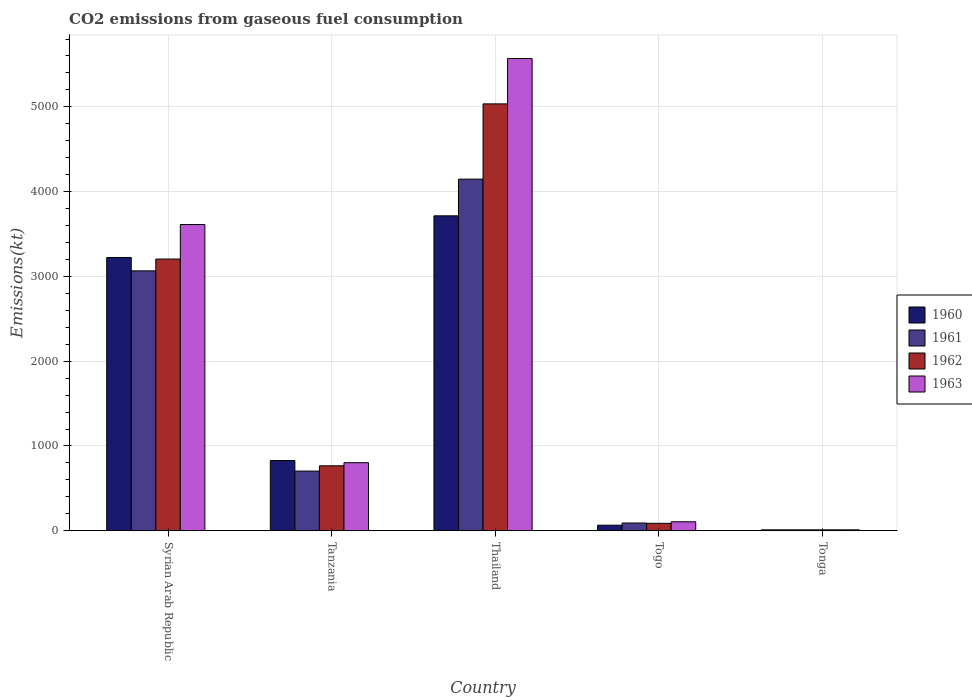How many different coloured bars are there?
Offer a terse response. 4. How many groups of bars are there?
Provide a short and direct response. 5. Are the number of bars per tick equal to the number of legend labels?
Ensure brevity in your answer.  Yes. Are the number of bars on each tick of the X-axis equal?
Provide a succinct answer. Yes. What is the label of the 4th group of bars from the left?
Make the answer very short. Togo. In how many cases, is the number of bars for a given country not equal to the number of legend labels?
Keep it short and to the point. 0. What is the amount of CO2 emitted in 1960 in Syrian Arab Republic?
Your answer should be very brief. 3223.29. Across all countries, what is the maximum amount of CO2 emitted in 1962?
Give a very brief answer. 5034.79. Across all countries, what is the minimum amount of CO2 emitted in 1960?
Your answer should be compact. 11. In which country was the amount of CO2 emitted in 1961 maximum?
Your answer should be very brief. Thailand. In which country was the amount of CO2 emitted in 1960 minimum?
Ensure brevity in your answer.  Tonga. What is the total amount of CO2 emitted in 1962 in the graph?
Provide a succinct answer. 9105.16. What is the difference between the amount of CO2 emitted in 1962 in Tanzania and that in Tonga?
Offer a terse response. 755.4. What is the difference between the amount of CO2 emitted in 1960 in Tanzania and the amount of CO2 emitted in 1962 in Thailand?
Give a very brief answer. -4206.05. What is the average amount of CO2 emitted in 1960 per country?
Provide a succinct answer. 1568.74. What is the difference between the amount of CO2 emitted of/in 1962 and amount of CO2 emitted of/in 1963 in Thailand?
Provide a short and direct response. -535.38. What is the ratio of the amount of CO2 emitted in 1961 in Thailand to that in Togo?
Give a very brief answer. 45.24. Is the difference between the amount of CO2 emitted in 1962 in Togo and Tonga greater than the difference between the amount of CO2 emitted in 1963 in Togo and Tonga?
Your answer should be very brief. No. What is the difference between the highest and the second highest amount of CO2 emitted in 1962?
Offer a very short reply. 1829.83. What is the difference between the highest and the lowest amount of CO2 emitted in 1961?
Your answer should be compact. 4136.38. In how many countries, is the amount of CO2 emitted in 1961 greater than the average amount of CO2 emitted in 1961 taken over all countries?
Provide a succinct answer. 2. Is it the case that in every country, the sum of the amount of CO2 emitted in 1962 and amount of CO2 emitted in 1963 is greater than the sum of amount of CO2 emitted in 1961 and amount of CO2 emitted in 1960?
Offer a terse response. No. What does the 4th bar from the right in Thailand represents?
Make the answer very short. 1960. Are all the bars in the graph horizontal?
Your response must be concise. No. How many countries are there in the graph?
Offer a terse response. 5. Does the graph contain any zero values?
Provide a succinct answer. No. Does the graph contain grids?
Your response must be concise. Yes. Where does the legend appear in the graph?
Keep it short and to the point. Center right. How many legend labels are there?
Your answer should be very brief. 4. What is the title of the graph?
Offer a terse response. CO2 emissions from gaseous fuel consumption. What is the label or title of the Y-axis?
Ensure brevity in your answer.  Emissions(kt). What is the Emissions(kt) of 1960 in Syrian Arab Republic?
Your answer should be very brief. 3223.29. What is the Emissions(kt) of 1961 in Syrian Arab Republic?
Offer a very short reply. 3065.61. What is the Emissions(kt) in 1962 in Syrian Arab Republic?
Ensure brevity in your answer.  3204.96. What is the Emissions(kt) of 1963 in Syrian Arab Republic?
Provide a succinct answer. 3611.99. What is the Emissions(kt) of 1960 in Tanzania?
Give a very brief answer. 828.74. What is the Emissions(kt) in 1961 in Tanzania?
Your answer should be compact. 704.06. What is the Emissions(kt) in 1962 in Tanzania?
Your response must be concise. 766.4. What is the Emissions(kt) in 1963 in Tanzania?
Give a very brief answer. 803.07. What is the Emissions(kt) in 1960 in Thailand?
Your response must be concise. 3714.67. What is the Emissions(kt) in 1961 in Thailand?
Provide a short and direct response. 4147.38. What is the Emissions(kt) of 1962 in Thailand?
Give a very brief answer. 5034.79. What is the Emissions(kt) in 1963 in Thailand?
Offer a very short reply. 5570.17. What is the Emissions(kt) of 1960 in Togo?
Ensure brevity in your answer.  66.01. What is the Emissions(kt) of 1961 in Togo?
Keep it short and to the point. 91.67. What is the Emissions(kt) of 1962 in Togo?
Your answer should be very brief. 88.01. What is the Emissions(kt) of 1963 in Togo?
Give a very brief answer. 106.34. What is the Emissions(kt) in 1960 in Tonga?
Offer a very short reply. 11. What is the Emissions(kt) in 1961 in Tonga?
Your answer should be compact. 11. What is the Emissions(kt) of 1962 in Tonga?
Keep it short and to the point. 11. What is the Emissions(kt) of 1963 in Tonga?
Give a very brief answer. 11. Across all countries, what is the maximum Emissions(kt) in 1960?
Provide a succinct answer. 3714.67. Across all countries, what is the maximum Emissions(kt) of 1961?
Provide a short and direct response. 4147.38. Across all countries, what is the maximum Emissions(kt) of 1962?
Provide a short and direct response. 5034.79. Across all countries, what is the maximum Emissions(kt) in 1963?
Your answer should be very brief. 5570.17. Across all countries, what is the minimum Emissions(kt) in 1960?
Offer a terse response. 11. Across all countries, what is the minimum Emissions(kt) of 1961?
Your answer should be compact. 11. Across all countries, what is the minimum Emissions(kt) in 1962?
Provide a short and direct response. 11. Across all countries, what is the minimum Emissions(kt) in 1963?
Your response must be concise. 11. What is the total Emissions(kt) in 1960 in the graph?
Keep it short and to the point. 7843.71. What is the total Emissions(kt) in 1961 in the graph?
Your answer should be compact. 8019.73. What is the total Emissions(kt) of 1962 in the graph?
Ensure brevity in your answer.  9105.16. What is the total Emissions(kt) of 1963 in the graph?
Provide a succinct answer. 1.01e+04. What is the difference between the Emissions(kt) in 1960 in Syrian Arab Republic and that in Tanzania?
Your response must be concise. 2394.55. What is the difference between the Emissions(kt) of 1961 in Syrian Arab Republic and that in Tanzania?
Provide a short and direct response. 2361.55. What is the difference between the Emissions(kt) in 1962 in Syrian Arab Republic and that in Tanzania?
Keep it short and to the point. 2438.55. What is the difference between the Emissions(kt) of 1963 in Syrian Arab Republic and that in Tanzania?
Provide a short and direct response. 2808.92. What is the difference between the Emissions(kt) of 1960 in Syrian Arab Republic and that in Thailand?
Provide a succinct answer. -491.38. What is the difference between the Emissions(kt) in 1961 in Syrian Arab Republic and that in Thailand?
Your response must be concise. -1081.77. What is the difference between the Emissions(kt) of 1962 in Syrian Arab Republic and that in Thailand?
Your response must be concise. -1829.83. What is the difference between the Emissions(kt) in 1963 in Syrian Arab Republic and that in Thailand?
Give a very brief answer. -1958.18. What is the difference between the Emissions(kt) in 1960 in Syrian Arab Republic and that in Togo?
Offer a very short reply. 3157.29. What is the difference between the Emissions(kt) in 1961 in Syrian Arab Republic and that in Togo?
Keep it short and to the point. 2973.94. What is the difference between the Emissions(kt) of 1962 in Syrian Arab Republic and that in Togo?
Make the answer very short. 3116.95. What is the difference between the Emissions(kt) in 1963 in Syrian Arab Republic and that in Togo?
Offer a terse response. 3505.65. What is the difference between the Emissions(kt) of 1960 in Syrian Arab Republic and that in Tonga?
Keep it short and to the point. 3212.29. What is the difference between the Emissions(kt) of 1961 in Syrian Arab Republic and that in Tonga?
Offer a terse response. 3054.61. What is the difference between the Emissions(kt) in 1962 in Syrian Arab Republic and that in Tonga?
Provide a short and direct response. 3193.96. What is the difference between the Emissions(kt) of 1963 in Syrian Arab Republic and that in Tonga?
Your answer should be compact. 3600.99. What is the difference between the Emissions(kt) in 1960 in Tanzania and that in Thailand?
Your response must be concise. -2885.93. What is the difference between the Emissions(kt) in 1961 in Tanzania and that in Thailand?
Your response must be concise. -3443.31. What is the difference between the Emissions(kt) of 1962 in Tanzania and that in Thailand?
Give a very brief answer. -4268.39. What is the difference between the Emissions(kt) of 1963 in Tanzania and that in Thailand?
Keep it short and to the point. -4767.1. What is the difference between the Emissions(kt) in 1960 in Tanzania and that in Togo?
Make the answer very short. 762.74. What is the difference between the Emissions(kt) in 1961 in Tanzania and that in Togo?
Make the answer very short. 612.39. What is the difference between the Emissions(kt) in 1962 in Tanzania and that in Togo?
Your answer should be compact. 678.39. What is the difference between the Emissions(kt) in 1963 in Tanzania and that in Togo?
Ensure brevity in your answer.  696.73. What is the difference between the Emissions(kt) in 1960 in Tanzania and that in Tonga?
Your response must be concise. 817.74. What is the difference between the Emissions(kt) in 1961 in Tanzania and that in Tonga?
Ensure brevity in your answer.  693.06. What is the difference between the Emissions(kt) of 1962 in Tanzania and that in Tonga?
Make the answer very short. 755.4. What is the difference between the Emissions(kt) in 1963 in Tanzania and that in Tonga?
Offer a very short reply. 792.07. What is the difference between the Emissions(kt) in 1960 in Thailand and that in Togo?
Offer a terse response. 3648.66. What is the difference between the Emissions(kt) of 1961 in Thailand and that in Togo?
Offer a terse response. 4055.7. What is the difference between the Emissions(kt) of 1962 in Thailand and that in Togo?
Your response must be concise. 4946.78. What is the difference between the Emissions(kt) of 1963 in Thailand and that in Togo?
Give a very brief answer. 5463.83. What is the difference between the Emissions(kt) of 1960 in Thailand and that in Tonga?
Offer a terse response. 3703.67. What is the difference between the Emissions(kt) of 1961 in Thailand and that in Tonga?
Your answer should be very brief. 4136.38. What is the difference between the Emissions(kt) of 1962 in Thailand and that in Tonga?
Your response must be concise. 5023.79. What is the difference between the Emissions(kt) of 1963 in Thailand and that in Tonga?
Your answer should be compact. 5559.17. What is the difference between the Emissions(kt) in 1960 in Togo and that in Tonga?
Ensure brevity in your answer.  55.01. What is the difference between the Emissions(kt) in 1961 in Togo and that in Tonga?
Your answer should be very brief. 80.67. What is the difference between the Emissions(kt) of 1962 in Togo and that in Tonga?
Provide a short and direct response. 77.01. What is the difference between the Emissions(kt) in 1963 in Togo and that in Tonga?
Your answer should be compact. 95.34. What is the difference between the Emissions(kt) in 1960 in Syrian Arab Republic and the Emissions(kt) in 1961 in Tanzania?
Offer a terse response. 2519.23. What is the difference between the Emissions(kt) of 1960 in Syrian Arab Republic and the Emissions(kt) of 1962 in Tanzania?
Ensure brevity in your answer.  2456.89. What is the difference between the Emissions(kt) in 1960 in Syrian Arab Republic and the Emissions(kt) in 1963 in Tanzania?
Make the answer very short. 2420.22. What is the difference between the Emissions(kt) of 1961 in Syrian Arab Republic and the Emissions(kt) of 1962 in Tanzania?
Give a very brief answer. 2299.21. What is the difference between the Emissions(kt) in 1961 in Syrian Arab Republic and the Emissions(kt) in 1963 in Tanzania?
Your answer should be very brief. 2262.54. What is the difference between the Emissions(kt) of 1962 in Syrian Arab Republic and the Emissions(kt) of 1963 in Tanzania?
Make the answer very short. 2401.89. What is the difference between the Emissions(kt) in 1960 in Syrian Arab Republic and the Emissions(kt) in 1961 in Thailand?
Provide a short and direct response. -924.08. What is the difference between the Emissions(kt) in 1960 in Syrian Arab Republic and the Emissions(kt) in 1962 in Thailand?
Your answer should be compact. -1811.5. What is the difference between the Emissions(kt) in 1960 in Syrian Arab Republic and the Emissions(kt) in 1963 in Thailand?
Make the answer very short. -2346.88. What is the difference between the Emissions(kt) of 1961 in Syrian Arab Republic and the Emissions(kt) of 1962 in Thailand?
Provide a short and direct response. -1969.18. What is the difference between the Emissions(kt) of 1961 in Syrian Arab Republic and the Emissions(kt) of 1963 in Thailand?
Your answer should be compact. -2504.56. What is the difference between the Emissions(kt) of 1962 in Syrian Arab Republic and the Emissions(kt) of 1963 in Thailand?
Make the answer very short. -2365.22. What is the difference between the Emissions(kt) of 1960 in Syrian Arab Republic and the Emissions(kt) of 1961 in Togo?
Keep it short and to the point. 3131.62. What is the difference between the Emissions(kt) in 1960 in Syrian Arab Republic and the Emissions(kt) in 1962 in Togo?
Ensure brevity in your answer.  3135.28. What is the difference between the Emissions(kt) in 1960 in Syrian Arab Republic and the Emissions(kt) in 1963 in Togo?
Your answer should be compact. 3116.95. What is the difference between the Emissions(kt) of 1961 in Syrian Arab Republic and the Emissions(kt) of 1962 in Togo?
Give a very brief answer. 2977.6. What is the difference between the Emissions(kt) of 1961 in Syrian Arab Republic and the Emissions(kt) of 1963 in Togo?
Provide a succinct answer. 2959.27. What is the difference between the Emissions(kt) in 1962 in Syrian Arab Republic and the Emissions(kt) in 1963 in Togo?
Your response must be concise. 3098.61. What is the difference between the Emissions(kt) of 1960 in Syrian Arab Republic and the Emissions(kt) of 1961 in Tonga?
Make the answer very short. 3212.29. What is the difference between the Emissions(kt) in 1960 in Syrian Arab Republic and the Emissions(kt) in 1962 in Tonga?
Keep it short and to the point. 3212.29. What is the difference between the Emissions(kt) of 1960 in Syrian Arab Republic and the Emissions(kt) of 1963 in Tonga?
Offer a terse response. 3212.29. What is the difference between the Emissions(kt) of 1961 in Syrian Arab Republic and the Emissions(kt) of 1962 in Tonga?
Ensure brevity in your answer.  3054.61. What is the difference between the Emissions(kt) of 1961 in Syrian Arab Republic and the Emissions(kt) of 1963 in Tonga?
Your answer should be compact. 3054.61. What is the difference between the Emissions(kt) in 1962 in Syrian Arab Republic and the Emissions(kt) in 1963 in Tonga?
Offer a terse response. 3193.96. What is the difference between the Emissions(kt) of 1960 in Tanzania and the Emissions(kt) of 1961 in Thailand?
Provide a short and direct response. -3318.64. What is the difference between the Emissions(kt) in 1960 in Tanzania and the Emissions(kt) in 1962 in Thailand?
Your answer should be compact. -4206.05. What is the difference between the Emissions(kt) of 1960 in Tanzania and the Emissions(kt) of 1963 in Thailand?
Keep it short and to the point. -4741.43. What is the difference between the Emissions(kt) of 1961 in Tanzania and the Emissions(kt) of 1962 in Thailand?
Your answer should be compact. -4330.73. What is the difference between the Emissions(kt) in 1961 in Tanzania and the Emissions(kt) in 1963 in Thailand?
Keep it short and to the point. -4866.11. What is the difference between the Emissions(kt) of 1962 in Tanzania and the Emissions(kt) of 1963 in Thailand?
Ensure brevity in your answer.  -4803.77. What is the difference between the Emissions(kt) in 1960 in Tanzania and the Emissions(kt) in 1961 in Togo?
Offer a terse response. 737.07. What is the difference between the Emissions(kt) of 1960 in Tanzania and the Emissions(kt) of 1962 in Togo?
Your answer should be very brief. 740.73. What is the difference between the Emissions(kt) of 1960 in Tanzania and the Emissions(kt) of 1963 in Togo?
Provide a succinct answer. 722.4. What is the difference between the Emissions(kt) in 1961 in Tanzania and the Emissions(kt) in 1962 in Togo?
Offer a terse response. 616.06. What is the difference between the Emissions(kt) in 1961 in Tanzania and the Emissions(kt) in 1963 in Togo?
Provide a succinct answer. 597.72. What is the difference between the Emissions(kt) of 1962 in Tanzania and the Emissions(kt) of 1963 in Togo?
Offer a terse response. 660.06. What is the difference between the Emissions(kt) of 1960 in Tanzania and the Emissions(kt) of 1961 in Tonga?
Offer a very short reply. 817.74. What is the difference between the Emissions(kt) of 1960 in Tanzania and the Emissions(kt) of 1962 in Tonga?
Your answer should be compact. 817.74. What is the difference between the Emissions(kt) of 1960 in Tanzania and the Emissions(kt) of 1963 in Tonga?
Your answer should be compact. 817.74. What is the difference between the Emissions(kt) in 1961 in Tanzania and the Emissions(kt) in 1962 in Tonga?
Ensure brevity in your answer.  693.06. What is the difference between the Emissions(kt) in 1961 in Tanzania and the Emissions(kt) in 1963 in Tonga?
Ensure brevity in your answer.  693.06. What is the difference between the Emissions(kt) of 1962 in Tanzania and the Emissions(kt) of 1963 in Tonga?
Provide a short and direct response. 755.4. What is the difference between the Emissions(kt) in 1960 in Thailand and the Emissions(kt) in 1961 in Togo?
Give a very brief answer. 3623. What is the difference between the Emissions(kt) of 1960 in Thailand and the Emissions(kt) of 1962 in Togo?
Offer a very short reply. 3626.66. What is the difference between the Emissions(kt) of 1960 in Thailand and the Emissions(kt) of 1963 in Togo?
Offer a terse response. 3608.33. What is the difference between the Emissions(kt) in 1961 in Thailand and the Emissions(kt) in 1962 in Togo?
Offer a very short reply. 4059.37. What is the difference between the Emissions(kt) of 1961 in Thailand and the Emissions(kt) of 1963 in Togo?
Offer a terse response. 4041.03. What is the difference between the Emissions(kt) of 1962 in Thailand and the Emissions(kt) of 1963 in Togo?
Provide a succinct answer. 4928.45. What is the difference between the Emissions(kt) of 1960 in Thailand and the Emissions(kt) of 1961 in Tonga?
Offer a terse response. 3703.67. What is the difference between the Emissions(kt) of 1960 in Thailand and the Emissions(kt) of 1962 in Tonga?
Offer a terse response. 3703.67. What is the difference between the Emissions(kt) in 1960 in Thailand and the Emissions(kt) in 1963 in Tonga?
Your response must be concise. 3703.67. What is the difference between the Emissions(kt) in 1961 in Thailand and the Emissions(kt) in 1962 in Tonga?
Give a very brief answer. 4136.38. What is the difference between the Emissions(kt) in 1961 in Thailand and the Emissions(kt) in 1963 in Tonga?
Your response must be concise. 4136.38. What is the difference between the Emissions(kt) in 1962 in Thailand and the Emissions(kt) in 1963 in Tonga?
Your answer should be compact. 5023.79. What is the difference between the Emissions(kt) in 1960 in Togo and the Emissions(kt) in 1961 in Tonga?
Offer a terse response. 55.01. What is the difference between the Emissions(kt) of 1960 in Togo and the Emissions(kt) of 1962 in Tonga?
Your answer should be very brief. 55.01. What is the difference between the Emissions(kt) in 1960 in Togo and the Emissions(kt) in 1963 in Tonga?
Your answer should be very brief. 55.01. What is the difference between the Emissions(kt) in 1961 in Togo and the Emissions(kt) in 1962 in Tonga?
Offer a very short reply. 80.67. What is the difference between the Emissions(kt) in 1961 in Togo and the Emissions(kt) in 1963 in Tonga?
Offer a terse response. 80.67. What is the difference between the Emissions(kt) in 1962 in Togo and the Emissions(kt) in 1963 in Tonga?
Your response must be concise. 77.01. What is the average Emissions(kt) of 1960 per country?
Your response must be concise. 1568.74. What is the average Emissions(kt) in 1961 per country?
Provide a succinct answer. 1603.95. What is the average Emissions(kt) of 1962 per country?
Offer a very short reply. 1821.03. What is the average Emissions(kt) of 1963 per country?
Give a very brief answer. 2020.52. What is the difference between the Emissions(kt) in 1960 and Emissions(kt) in 1961 in Syrian Arab Republic?
Make the answer very short. 157.68. What is the difference between the Emissions(kt) of 1960 and Emissions(kt) of 1962 in Syrian Arab Republic?
Make the answer very short. 18.34. What is the difference between the Emissions(kt) of 1960 and Emissions(kt) of 1963 in Syrian Arab Republic?
Offer a very short reply. -388.7. What is the difference between the Emissions(kt) of 1961 and Emissions(kt) of 1962 in Syrian Arab Republic?
Give a very brief answer. -139.35. What is the difference between the Emissions(kt) in 1961 and Emissions(kt) in 1963 in Syrian Arab Republic?
Offer a terse response. -546.38. What is the difference between the Emissions(kt) in 1962 and Emissions(kt) in 1963 in Syrian Arab Republic?
Give a very brief answer. -407.04. What is the difference between the Emissions(kt) in 1960 and Emissions(kt) in 1961 in Tanzania?
Your answer should be very brief. 124.68. What is the difference between the Emissions(kt) in 1960 and Emissions(kt) in 1962 in Tanzania?
Keep it short and to the point. 62.34. What is the difference between the Emissions(kt) in 1960 and Emissions(kt) in 1963 in Tanzania?
Make the answer very short. 25.67. What is the difference between the Emissions(kt) of 1961 and Emissions(kt) of 1962 in Tanzania?
Provide a succinct answer. -62.34. What is the difference between the Emissions(kt) of 1961 and Emissions(kt) of 1963 in Tanzania?
Your answer should be compact. -99.01. What is the difference between the Emissions(kt) in 1962 and Emissions(kt) in 1963 in Tanzania?
Offer a terse response. -36.67. What is the difference between the Emissions(kt) of 1960 and Emissions(kt) of 1961 in Thailand?
Give a very brief answer. -432.71. What is the difference between the Emissions(kt) in 1960 and Emissions(kt) in 1962 in Thailand?
Give a very brief answer. -1320.12. What is the difference between the Emissions(kt) of 1960 and Emissions(kt) of 1963 in Thailand?
Your response must be concise. -1855.5. What is the difference between the Emissions(kt) in 1961 and Emissions(kt) in 1962 in Thailand?
Provide a succinct answer. -887.41. What is the difference between the Emissions(kt) of 1961 and Emissions(kt) of 1963 in Thailand?
Keep it short and to the point. -1422.8. What is the difference between the Emissions(kt) in 1962 and Emissions(kt) in 1963 in Thailand?
Provide a short and direct response. -535.38. What is the difference between the Emissions(kt) in 1960 and Emissions(kt) in 1961 in Togo?
Provide a succinct answer. -25.67. What is the difference between the Emissions(kt) in 1960 and Emissions(kt) in 1962 in Togo?
Keep it short and to the point. -22. What is the difference between the Emissions(kt) in 1960 and Emissions(kt) in 1963 in Togo?
Offer a very short reply. -40.34. What is the difference between the Emissions(kt) in 1961 and Emissions(kt) in 1962 in Togo?
Your answer should be compact. 3.67. What is the difference between the Emissions(kt) in 1961 and Emissions(kt) in 1963 in Togo?
Your response must be concise. -14.67. What is the difference between the Emissions(kt) of 1962 and Emissions(kt) of 1963 in Togo?
Offer a terse response. -18.34. What is the difference between the Emissions(kt) in 1960 and Emissions(kt) in 1961 in Tonga?
Offer a terse response. 0. What is the difference between the Emissions(kt) of 1960 and Emissions(kt) of 1962 in Tonga?
Keep it short and to the point. 0. What is the difference between the Emissions(kt) in 1961 and Emissions(kt) in 1962 in Tonga?
Keep it short and to the point. 0. What is the ratio of the Emissions(kt) of 1960 in Syrian Arab Republic to that in Tanzania?
Your answer should be very brief. 3.89. What is the ratio of the Emissions(kt) in 1961 in Syrian Arab Republic to that in Tanzania?
Make the answer very short. 4.35. What is the ratio of the Emissions(kt) in 1962 in Syrian Arab Republic to that in Tanzania?
Offer a very short reply. 4.18. What is the ratio of the Emissions(kt) of 1963 in Syrian Arab Republic to that in Tanzania?
Offer a very short reply. 4.5. What is the ratio of the Emissions(kt) in 1960 in Syrian Arab Republic to that in Thailand?
Your response must be concise. 0.87. What is the ratio of the Emissions(kt) in 1961 in Syrian Arab Republic to that in Thailand?
Offer a very short reply. 0.74. What is the ratio of the Emissions(kt) of 1962 in Syrian Arab Republic to that in Thailand?
Provide a short and direct response. 0.64. What is the ratio of the Emissions(kt) in 1963 in Syrian Arab Republic to that in Thailand?
Give a very brief answer. 0.65. What is the ratio of the Emissions(kt) in 1960 in Syrian Arab Republic to that in Togo?
Give a very brief answer. 48.83. What is the ratio of the Emissions(kt) in 1961 in Syrian Arab Republic to that in Togo?
Keep it short and to the point. 33.44. What is the ratio of the Emissions(kt) in 1962 in Syrian Arab Republic to that in Togo?
Make the answer very short. 36.42. What is the ratio of the Emissions(kt) in 1963 in Syrian Arab Republic to that in Togo?
Provide a succinct answer. 33.97. What is the ratio of the Emissions(kt) of 1960 in Syrian Arab Republic to that in Tonga?
Your response must be concise. 293. What is the ratio of the Emissions(kt) in 1961 in Syrian Arab Republic to that in Tonga?
Provide a short and direct response. 278.67. What is the ratio of the Emissions(kt) in 1962 in Syrian Arab Republic to that in Tonga?
Keep it short and to the point. 291.33. What is the ratio of the Emissions(kt) in 1963 in Syrian Arab Republic to that in Tonga?
Your answer should be compact. 328.33. What is the ratio of the Emissions(kt) of 1960 in Tanzania to that in Thailand?
Make the answer very short. 0.22. What is the ratio of the Emissions(kt) in 1961 in Tanzania to that in Thailand?
Your answer should be very brief. 0.17. What is the ratio of the Emissions(kt) of 1962 in Tanzania to that in Thailand?
Keep it short and to the point. 0.15. What is the ratio of the Emissions(kt) of 1963 in Tanzania to that in Thailand?
Provide a short and direct response. 0.14. What is the ratio of the Emissions(kt) of 1960 in Tanzania to that in Togo?
Keep it short and to the point. 12.56. What is the ratio of the Emissions(kt) of 1961 in Tanzania to that in Togo?
Ensure brevity in your answer.  7.68. What is the ratio of the Emissions(kt) in 1962 in Tanzania to that in Togo?
Your response must be concise. 8.71. What is the ratio of the Emissions(kt) of 1963 in Tanzania to that in Togo?
Offer a terse response. 7.55. What is the ratio of the Emissions(kt) in 1960 in Tanzania to that in Tonga?
Keep it short and to the point. 75.33. What is the ratio of the Emissions(kt) in 1962 in Tanzania to that in Tonga?
Your answer should be very brief. 69.67. What is the ratio of the Emissions(kt) in 1963 in Tanzania to that in Tonga?
Your response must be concise. 73. What is the ratio of the Emissions(kt) in 1960 in Thailand to that in Togo?
Offer a terse response. 56.28. What is the ratio of the Emissions(kt) in 1961 in Thailand to that in Togo?
Your answer should be very brief. 45.24. What is the ratio of the Emissions(kt) in 1962 in Thailand to that in Togo?
Offer a terse response. 57.21. What is the ratio of the Emissions(kt) of 1963 in Thailand to that in Togo?
Give a very brief answer. 52.38. What is the ratio of the Emissions(kt) in 1960 in Thailand to that in Tonga?
Give a very brief answer. 337.67. What is the ratio of the Emissions(kt) of 1961 in Thailand to that in Tonga?
Ensure brevity in your answer.  377. What is the ratio of the Emissions(kt) in 1962 in Thailand to that in Tonga?
Provide a succinct answer. 457.67. What is the ratio of the Emissions(kt) in 1963 in Thailand to that in Tonga?
Offer a very short reply. 506.33. What is the ratio of the Emissions(kt) of 1960 in Togo to that in Tonga?
Your answer should be very brief. 6. What is the ratio of the Emissions(kt) of 1961 in Togo to that in Tonga?
Your answer should be compact. 8.33. What is the ratio of the Emissions(kt) in 1962 in Togo to that in Tonga?
Offer a terse response. 8. What is the ratio of the Emissions(kt) of 1963 in Togo to that in Tonga?
Provide a short and direct response. 9.67. What is the difference between the highest and the second highest Emissions(kt) of 1960?
Your answer should be very brief. 491.38. What is the difference between the highest and the second highest Emissions(kt) of 1961?
Ensure brevity in your answer.  1081.77. What is the difference between the highest and the second highest Emissions(kt) in 1962?
Your response must be concise. 1829.83. What is the difference between the highest and the second highest Emissions(kt) in 1963?
Provide a short and direct response. 1958.18. What is the difference between the highest and the lowest Emissions(kt) in 1960?
Ensure brevity in your answer.  3703.67. What is the difference between the highest and the lowest Emissions(kt) in 1961?
Your answer should be compact. 4136.38. What is the difference between the highest and the lowest Emissions(kt) of 1962?
Give a very brief answer. 5023.79. What is the difference between the highest and the lowest Emissions(kt) of 1963?
Offer a terse response. 5559.17. 